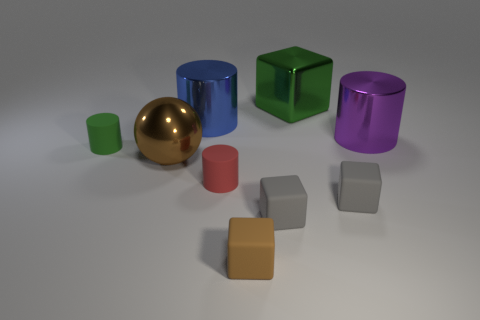Is there a purple cylinder made of the same material as the green cylinder?
Provide a short and direct response. No. There is a cylinder in front of the green thing in front of the purple cylinder; is there a red matte cylinder that is on the right side of it?
Offer a very short reply. No. What number of other things are there of the same shape as the large blue object?
Give a very brief answer. 3. What color is the matte cylinder behind the large object that is in front of the cylinder on the right side of the brown cube?
Make the answer very short. Green. What number of large purple shiny cylinders are there?
Your response must be concise. 1. What number of small objects are either spheres or gray matte cubes?
Ensure brevity in your answer.  2. What shape is the green metal object that is the same size as the metallic sphere?
Keep it short and to the point. Cube. Is there anything else that is the same size as the blue metallic cylinder?
Your answer should be compact. Yes. What is the material of the small brown object to the right of the tiny matte cylinder that is behind the red rubber thing?
Your answer should be very brief. Rubber. Is the size of the green metal object the same as the red cylinder?
Provide a succinct answer. No. 